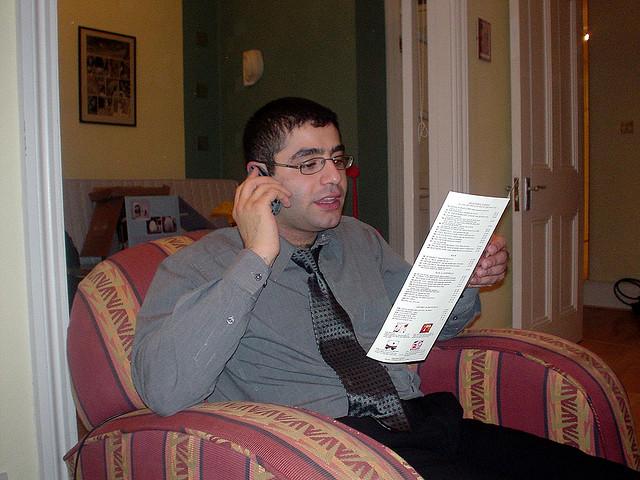What is the man talking on?
Be succinct. Cell phone. Do the colors in the man's tie match his shirt and/or slacks?
Answer briefly. Yes. What is the man holding in his hands?
Write a very short answer. Menu. Is the man ordering take out?
Be succinct. Yes. 